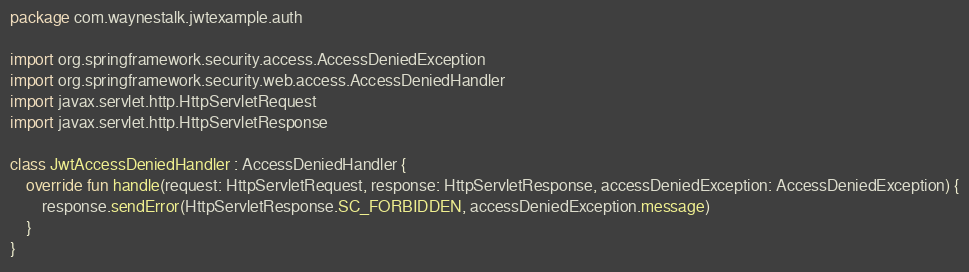Convert code to text. <code><loc_0><loc_0><loc_500><loc_500><_Kotlin_>package com.waynestalk.jwtexample.auth

import org.springframework.security.access.AccessDeniedException
import org.springframework.security.web.access.AccessDeniedHandler
import javax.servlet.http.HttpServletRequest
import javax.servlet.http.HttpServletResponse

class JwtAccessDeniedHandler : AccessDeniedHandler {
    override fun handle(request: HttpServletRequest, response: HttpServletResponse, accessDeniedException: AccessDeniedException) {
        response.sendError(HttpServletResponse.SC_FORBIDDEN, accessDeniedException.message)
    }
}</code> 